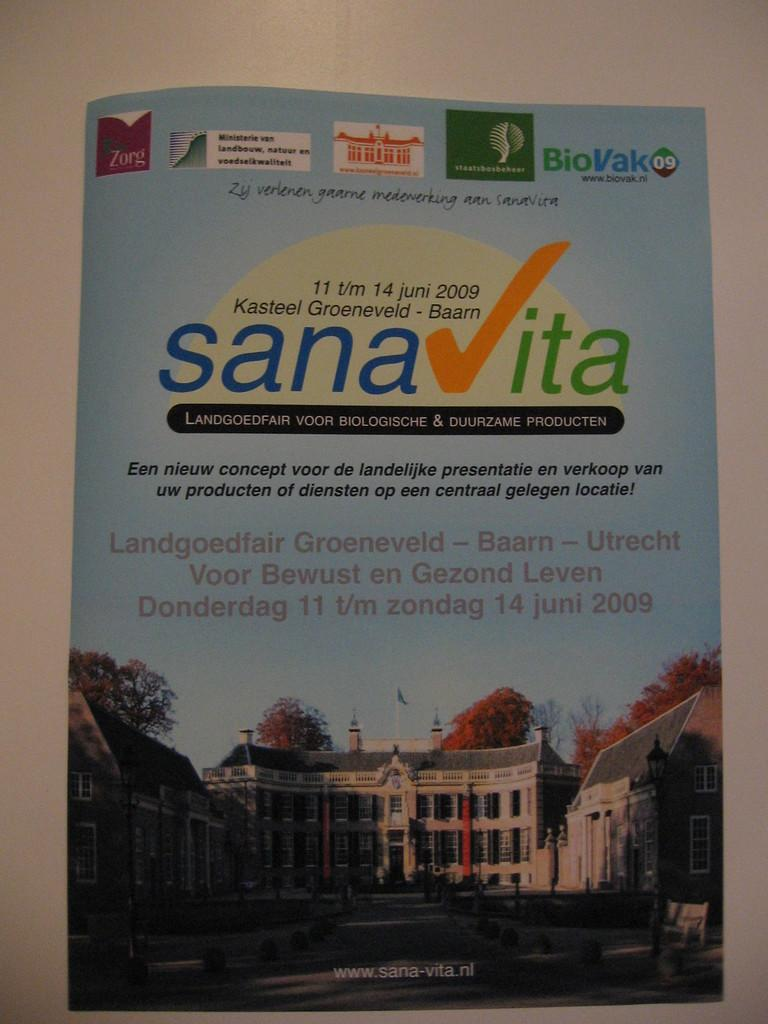<image>
Relay a brief, clear account of the picture shown. A poster showing a very large house describing the benfits of Sanavita. 